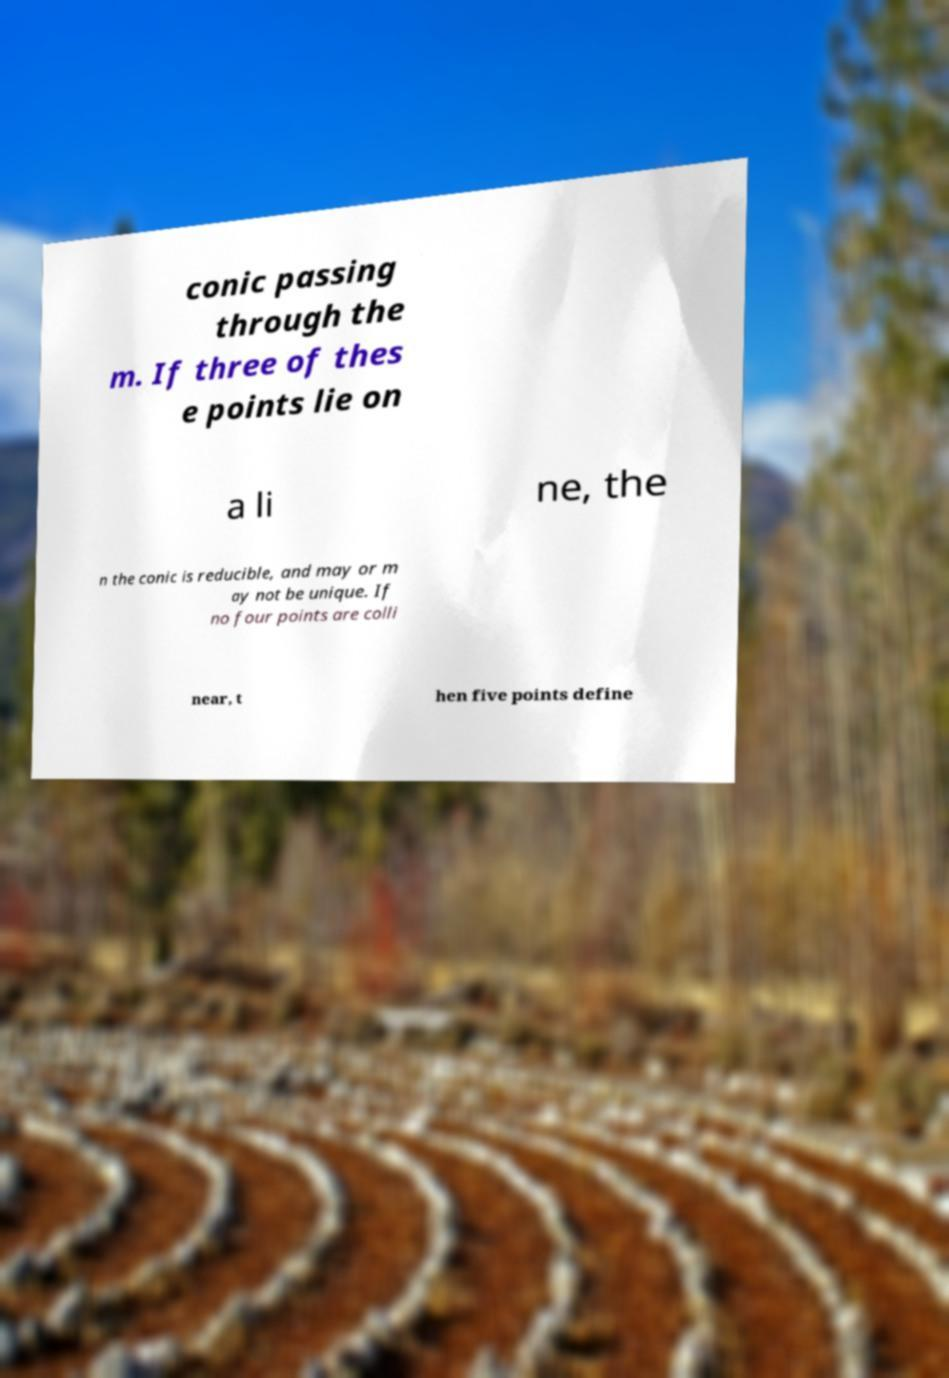For documentation purposes, I need the text within this image transcribed. Could you provide that? conic passing through the m. If three of thes e points lie on a li ne, the n the conic is reducible, and may or m ay not be unique. If no four points are colli near, t hen five points define 